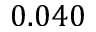Convert formula to latex. <formula><loc_0><loc_0><loc_500><loc_500>0 . 0 4 0</formula> 